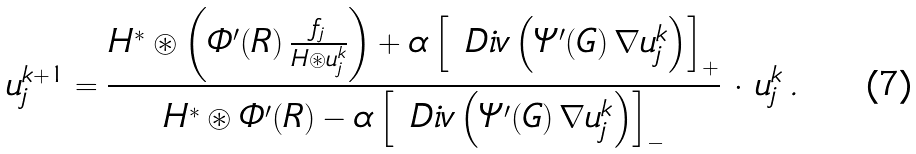<formula> <loc_0><loc_0><loc_500><loc_500>u _ { j } ^ { k + 1 } = \frac { H ^ { * } \circledast \left ( \varPhi ^ { \prime } ( R ) \, \frac { f _ { j } } { H \circledast u _ { j } ^ { k } } \right ) + \alpha \left [ \ D i v \left ( \varPsi ^ { \prime } ( G ) \, \nabla u _ { j } ^ { k } \right ) \right ] _ { + } } { H ^ { * } \circledast \varPhi ^ { \prime } ( R ) - \alpha \left [ \ D i v \left ( \varPsi ^ { \prime } ( G ) \, \nabla u _ { j } ^ { k } \right ) \right ] _ { - } } \, \cdot \, u _ { j } ^ { k } \, .</formula> 